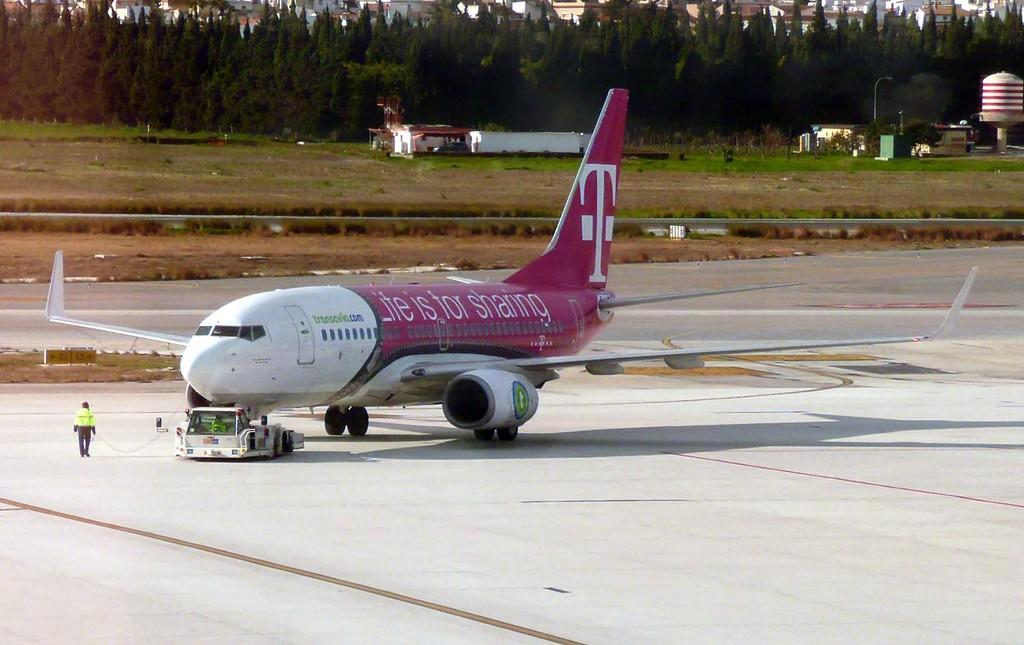<image>
Provide a brief description of the given image. A commercial jet is being towed on a runway and its painted with a T-Mobile ad. 